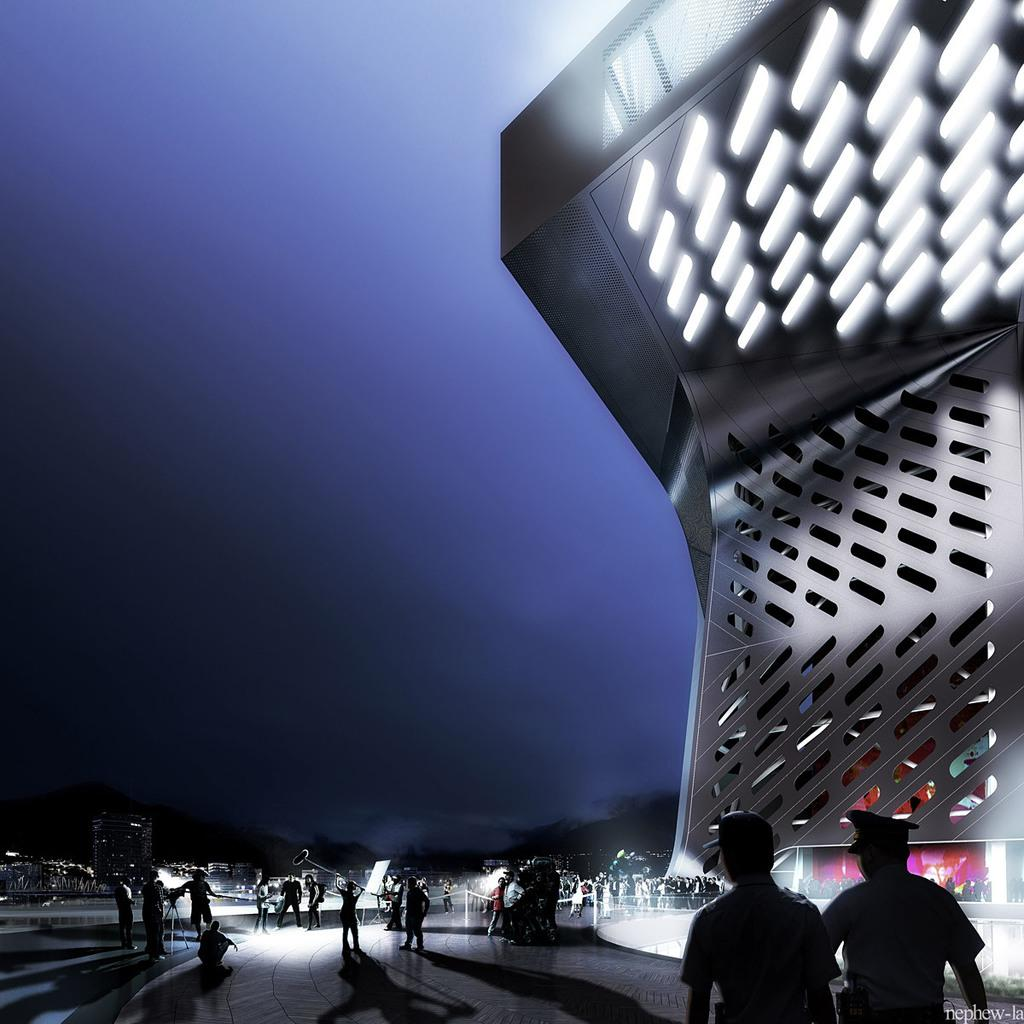What are the people in the image doing? The people in the image are standing and walking in the center of the image. Can you describe the structure on the right side of the image? Unfortunately, the provided facts do not give any details about the structure on the right side of the image. What type of lace is being used to decorate the dog's collar in the image? There is no dog present in the image, so there is no collar or lace to describe. 